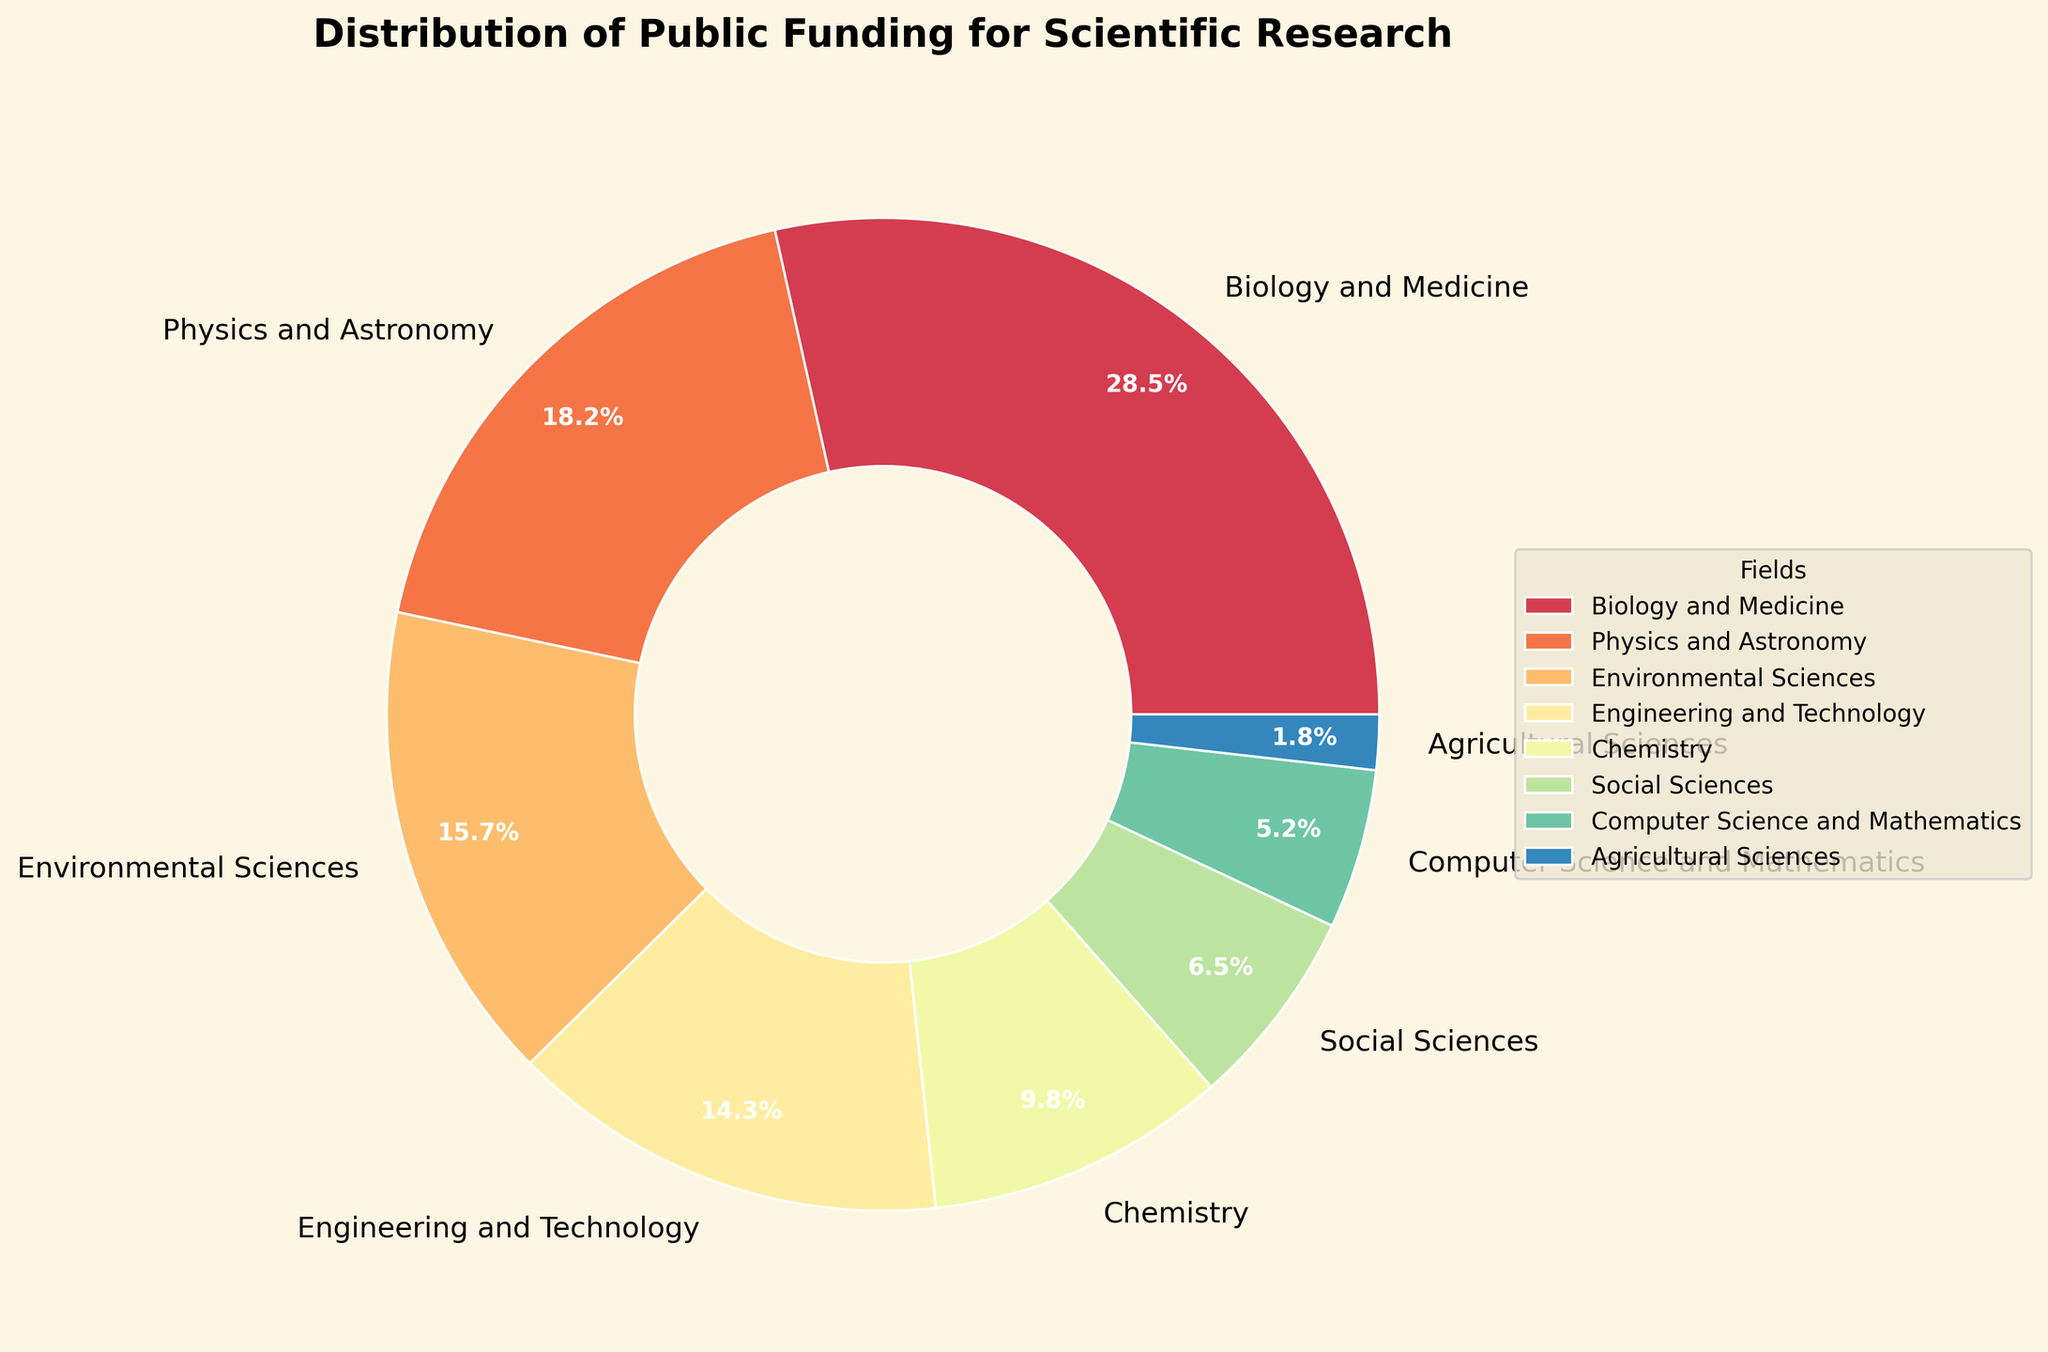What is the field with the highest percentage of public funding? The field with the highest percentage of public funding is represented by the largest slice in the pie chart.
Answer: Biology and Medicine How much more funding percentage does Physics and Astronomy get compared to Computer Science and Mathematics? Subtract the percentage of funding for Computer Science and Mathematics from the percentage for Physics and Astronomy (18.2 - 5.2).
Answer: 13 Which fields receive less than 10% of the public funding? Identify the slices in the pie chart that correspond to less than 10% of the total funding.
Answer: Social Sciences, Computer Science and Mathematics, Agricultural Sciences What is the combined funding percentage for Environmental Sciences, Engineering and Technology, and Chemistry? Add the percentages for the three fields together (15.7 + 14.3 + 9.8).
Answer: 39.8 By how much does the funding percentage for Biology and Medicine exceed that for Social Sciences? Subtract the percentage for Social Sciences from the percentage for Biology and Medicine (28.5 - 6.5).
Answer: 22 What is the combined percentage of funding for the top 3 funded fields? Identify the top 3 fields (Biology and Medicine, Physics and Astronomy, Environmental Sciences) and add their percentages (28.5 + 18.2 + 15.7).
Answer: 62.4 How does the funding for Agricultural Sciences compare visually to the other fields? The slice for Agricultural Sciences is noticeably smaller compared to the other slices in the pie chart.
Answer: It is the smallest What proportion of the chart represents fields other than Biology and Medicine and Physics and Astronomy? Subtract the percentages for Biology and Medicine and Physics and Astronomy from 100 (100 - 28.5 - 18.2).
Answer: 53.3 What is the visual impact of the wedge thickness in depicting funding differences? The wedges of the pie chart have differing thicknesses proportional to the funding percentages, making it easy to visually compare the funding levels across fields.
Answer: Thicker wedges represent higher funding percentages 